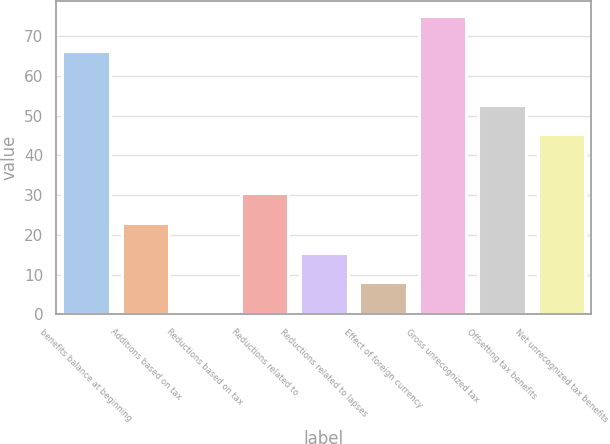Convert chart to OTSL. <chart><loc_0><loc_0><loc_500><loc_500><bar_chart><fcel>benefits balance at beginning<fcel>Additions based on tax<fcel>Reductions based on tax<fcel>Reductions related to<fcel>Reductions related to lapses<fcel>Effect of foreign currency<fcel>Gross unrecognized tax<fcel>Offsetting tax benefits<fcel>Net unrecognized tax benefits<nl><fcel>66.3<fcel>22.95<fcel>0.6<fcel>30.4<fcel>15.5<fcel>8.05<fcel>75.1<fcel>52.75<fcel>45.3<nl></chart> 